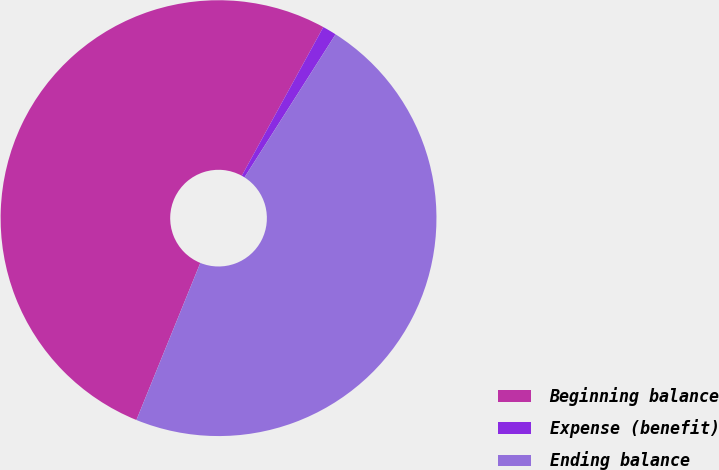Convert chart. <chart><loc_0><loc_0><loc_500><loc_500><pie_chart><fcel>Beginning balance<fcel>Expense (benefit)<fcel>Ending balance<nl><fcel>51.84%<fcel>1.04%<fcel>47.13%<nl></chart> 